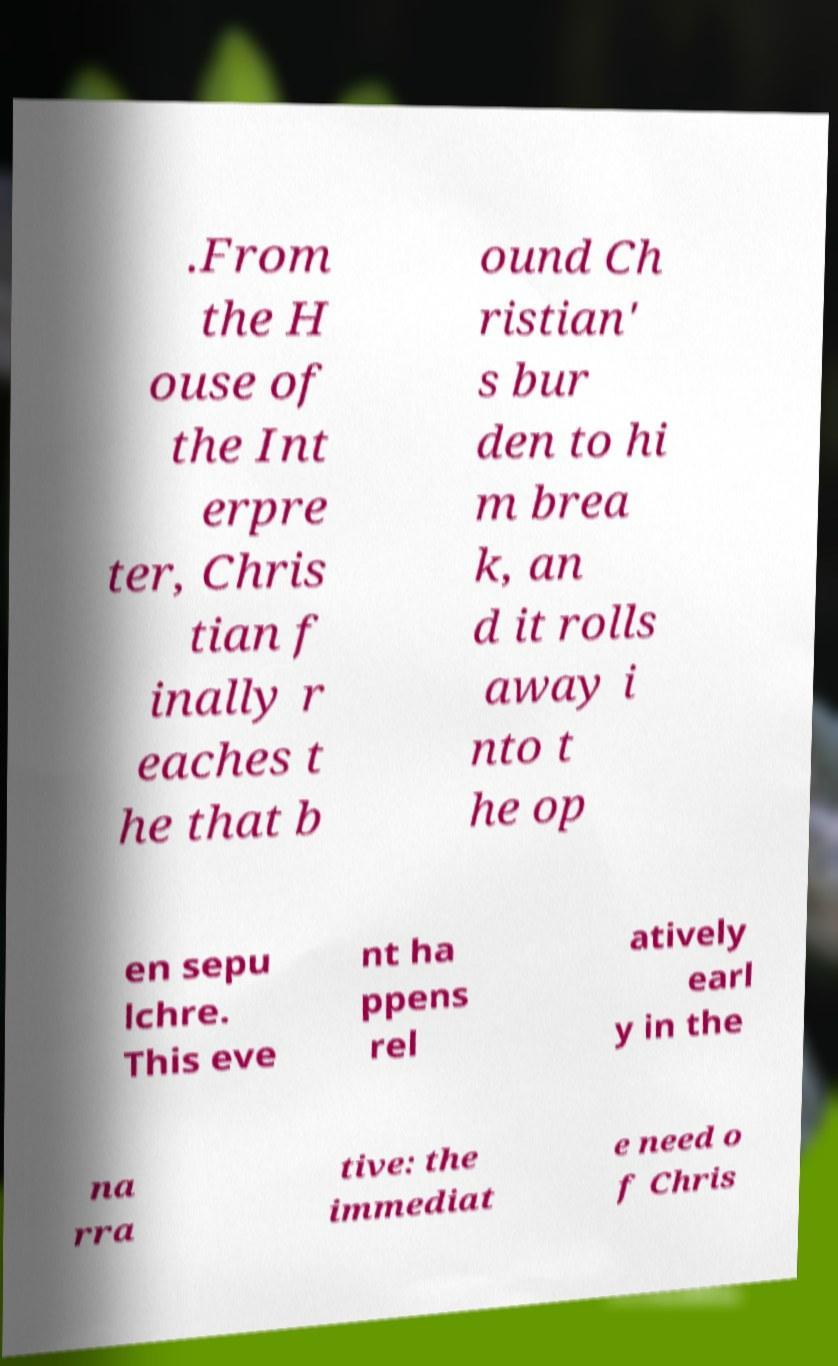For documentation purposes, I need the text within this image transcribed. Could you provide that? .From the H ouse of the Int erpre ter, Chris tian f inally r eaches t he that b ound Ch ristian' s bur den to hi m brea k, an d it rolls away i nto t he op en sepu lchre. This eve nt ha ppens rel atively earl y in the na rra tive: the immediat e need o f Chris 